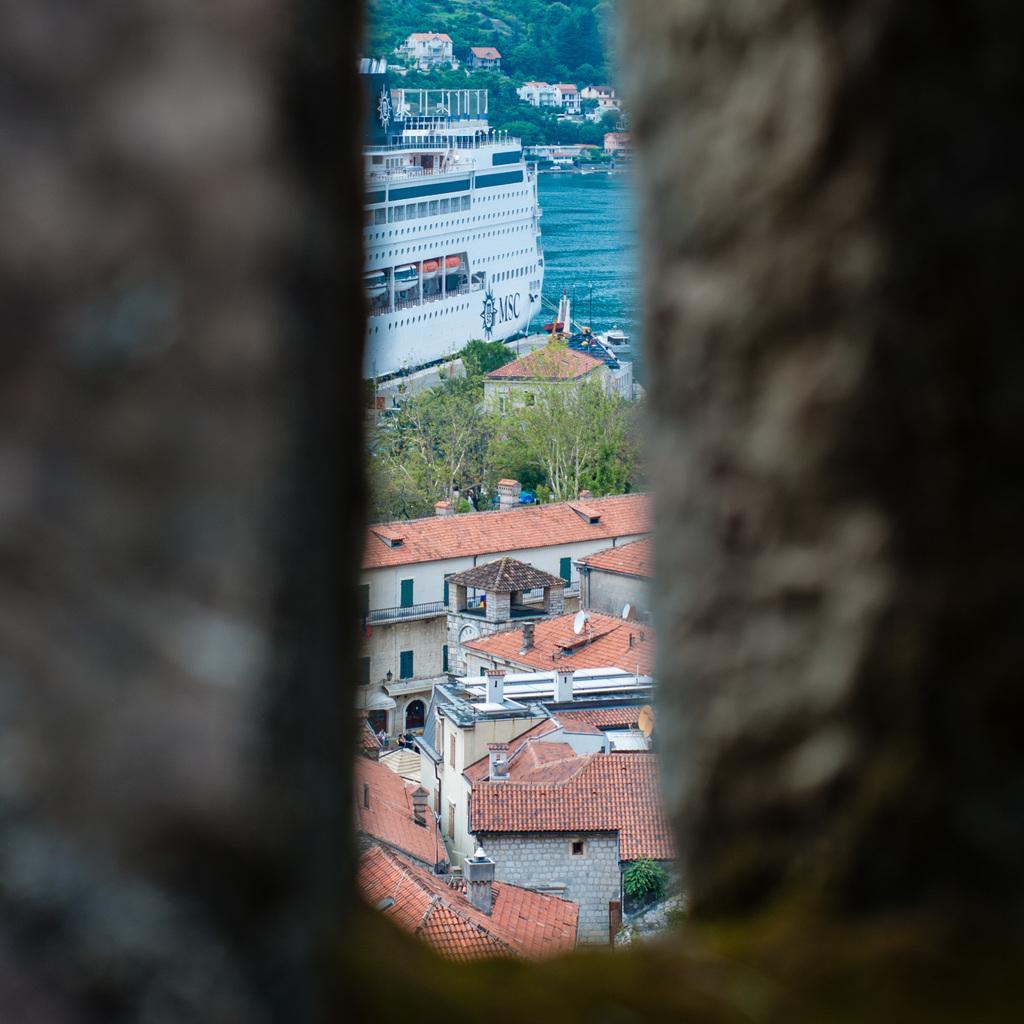Can you describe this image briefly? In this image I can see few buildings in brown and cream color, at back I can see ship in water which is in white color, trees in green color. 